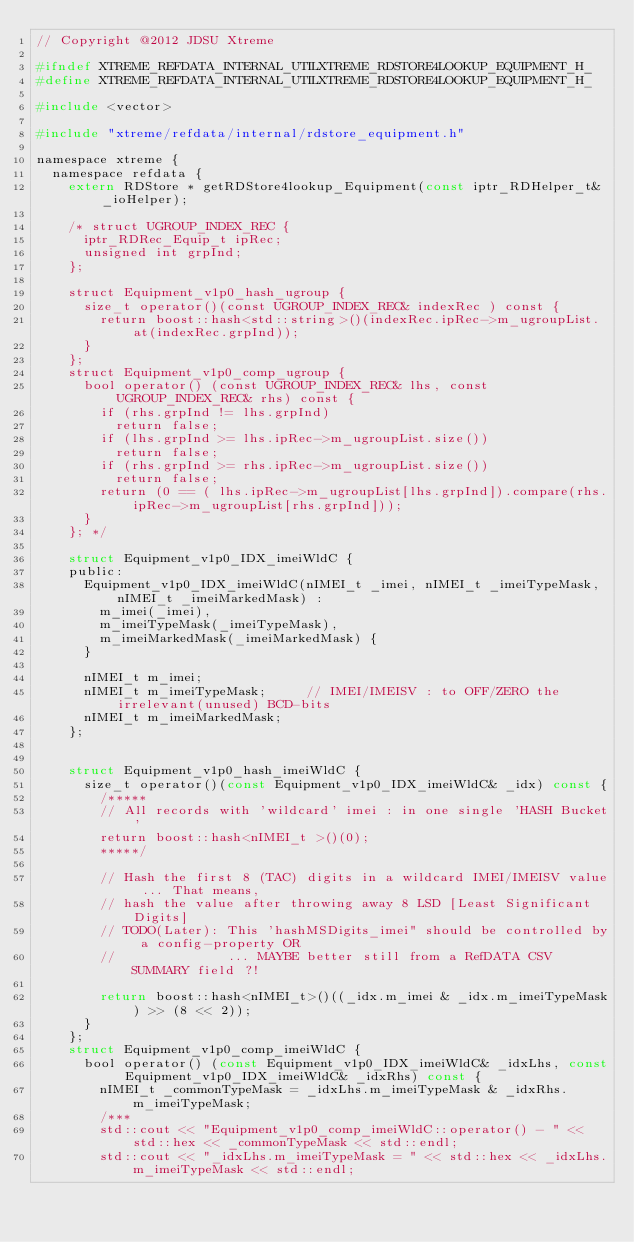Convert code to text. <code><loc_0><loc_0><loc_500><loc_500><_C_>// Copyright @2012 JDSU Xtreme

#ifndef XTREME_REFDATA_INTERNAL_UTILXTREME_RDSTORE4LOOKUP_EQUIPMENT_H_
#define XTREME_REFDATA_INTERNAL_UTILXTREME_RDSTORE4LOOKUP_EQUIPMENT_H_

#include <vector>

#include "xtreme/refdata/internal/rdstore_equipment.h"

namespace xtreme {
  namespace refdata {
    extern RDStore * getRDStore4lookup_Equipment(const iptr_RDHelper_t& _ioHelper);

    /* struct UGROUP_INDEX_REC {
      iptr_RDRec_Equip_t ipRec;
      unsigned int grpInd;
    };

    struct Equipment_v1p0_hash_ugroup {
      size_t operator()(const UGROUP_INDEX_REC& indexRec ) const {
        return boost::hash<std::string>()(indexRec.ipRec->m_ugroupList.at(indexRec.grpInd));
      }
    };
    struct Equipment_v1p0_comp_ugroup {
      bool operator() (const UGROUP_INDEX_REC& lhs, const UGROUP_INDEX_REC& rhs) const {
        if (rhs.grpInd != lhs.grpInd)
          return false;
        if (lhs.grpInd >= lhs.ipRec->m_ugroupList.size())
          return false;
        if (rhs.grpInd >= rhs.ipRec->m_ugroupList.size())
          return false;
        return (0 == ( lhs.ipRec->m_ugroupList[lhs.grpInd]).compare(rhs.ipRec->m_ugroupList[rhs.grpInd]));
      }
    }; */

    struct Equipment_v1p0_IDX_imeiWldC {
    public:
      Equipment_v1p0_IDX_imeiWldC(nIMEI_t _imei, nIMEI_t _imeiTypeMask, nIMEI_t _imeiMarkedMask) :
        m_imei(_imei),
        m_imeiTypeMask(_imeiTypeMask),
        m_imeiMarkedMask(_imeiMarkedMask) {
      }

      nIMEI_t m_imei;
      nIMEI_t m_imeiTypeMask;     // IMEI/IMEISV : to OFF/ZERO the irrelevant(unused) BCD-bits
      nIMEI_t m_imeiMarkedMask;
    };


    struct Equipment_v1p0_hash_imeiWldC {
      size_t operator()(const Equipment_v1p0_IDX_imeiWldC& _idx) const {
        /*****
        // All records with 'wildcard' imei : in one single 'HASH Bucket'
        return boost::hash<nIMEI_t >()(0);
        *****/

        // Hash the first 8 (TAC) digits in a wildcard IMEI/IMEISV value ... That means,
        // hash the value after throwing away 8 LSD [Least Significant Digits]
        // TODO(Later): This 'hashMSDigits_imei" should be controlled by a config-property OR
        //              ... MAYBE better still from a RefDATA CSV SUMMARY field ?!

        return boost::hash<nIMEI_t>()((_idx.m_imei & _idx.m_imeiTypeMask) >> (8 << 2));
      }
    };
    struct Equipment_v1p0_comp_imeiWldC {
      bool operator() (const Equipment_v1p0_IDX_imeiWldC& _idxLhs, const Equipment_v1p0_IDX_imeiWldC& _idxRhs) const {
        nIMEI_t _commonTypeMask = _idxLhs.m_imeiTypeMask & _idxRhs.m_imeiTypeMask;
        /***
        std::cout << "Equipment_v1p0_comp_imeiWldC::operator() - " << std::hex << _commonTypeMask << std::endl;
        std::cout << "_idxLhs.m_imeiTypeMask = " << std::hex << _idxLhs.m_imeiTypeMask << std::endl;</code> 